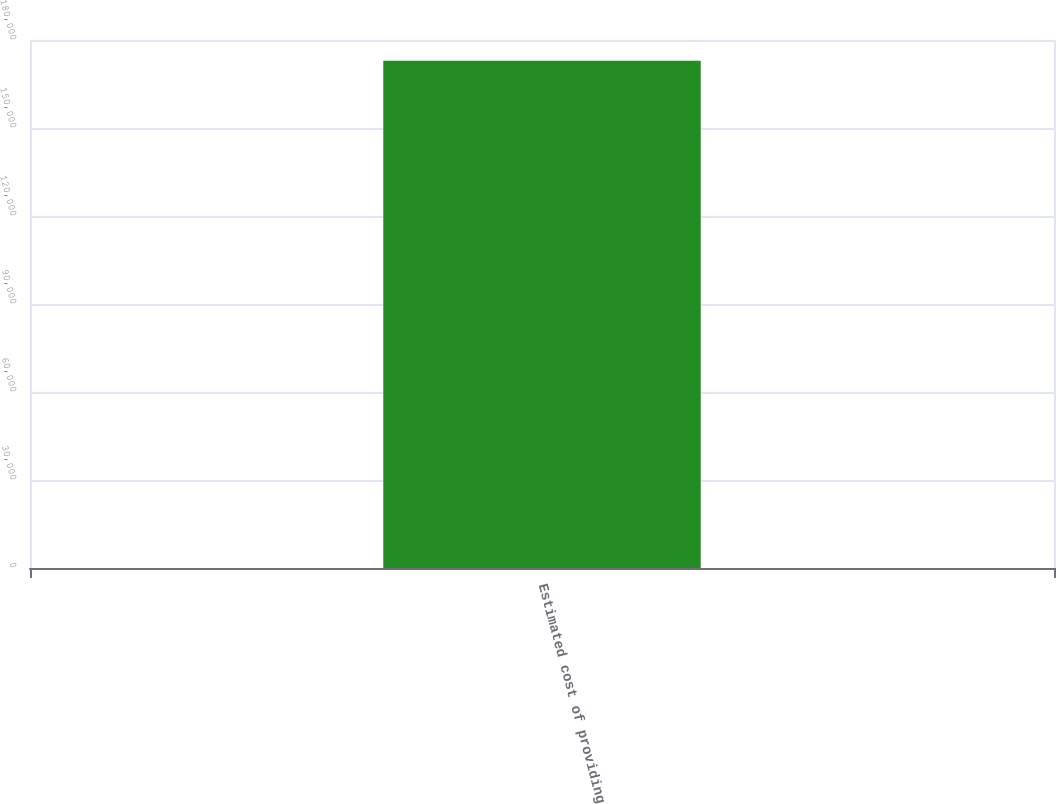<chart> <loc_0><loc_0><loc_500><loc_500><bar_chart><fcel>Estimated cost of providing<nl><fcel>172959<nl></chart> 